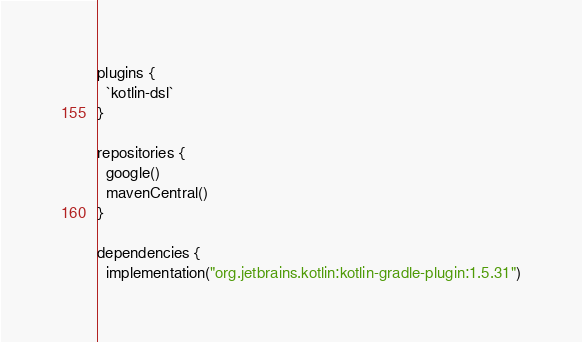<code> <loc_0><loc_0><loc_500><loc_500><_Kotlin_>plugins {
  `kotlin-dsl`
}

repositories {
  google()
  mavenCentral()
}

dependencies {
  implementation("org.jetbrains.kotlin:kotlin-gradle-plugin:1.5.31")</code> 